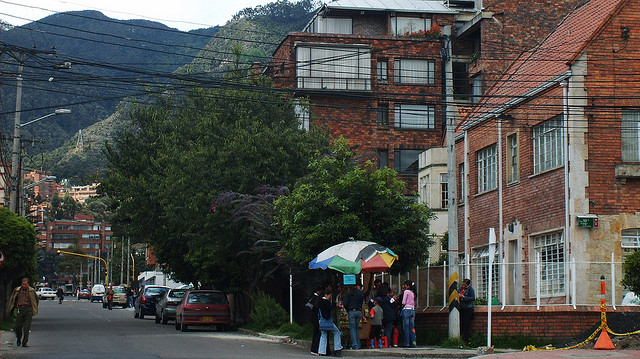What is the weather like in the image? The weather seems overcast with no direct sunlight visible, suggesting it could be a cloudy day. What activities are people engaged in on the street? The people appear to be walking along the sidewalk, some might be waiting for a bus, and one person is carrying an umbrella, potentially indicating recent or imminent rain. 